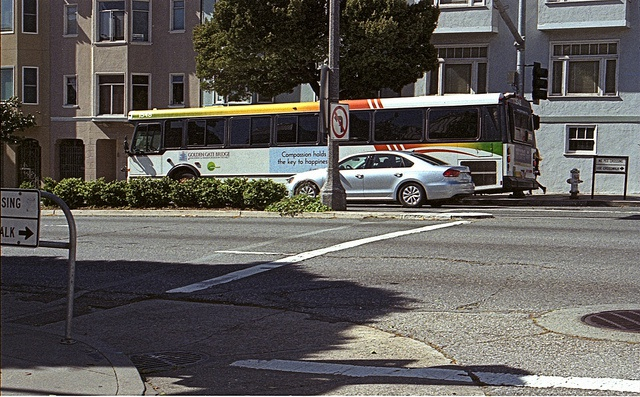Describe the objects in this image and their specific colors. I can see bus in maroon, black, lightgray, gray, and lightblue tones, car in maroon, black, white, gray, and darkgray tones, traffic light in maroon, black, gray, and darkgray tones, and fire hydrant in maroon, black, and gray tones in this image. 